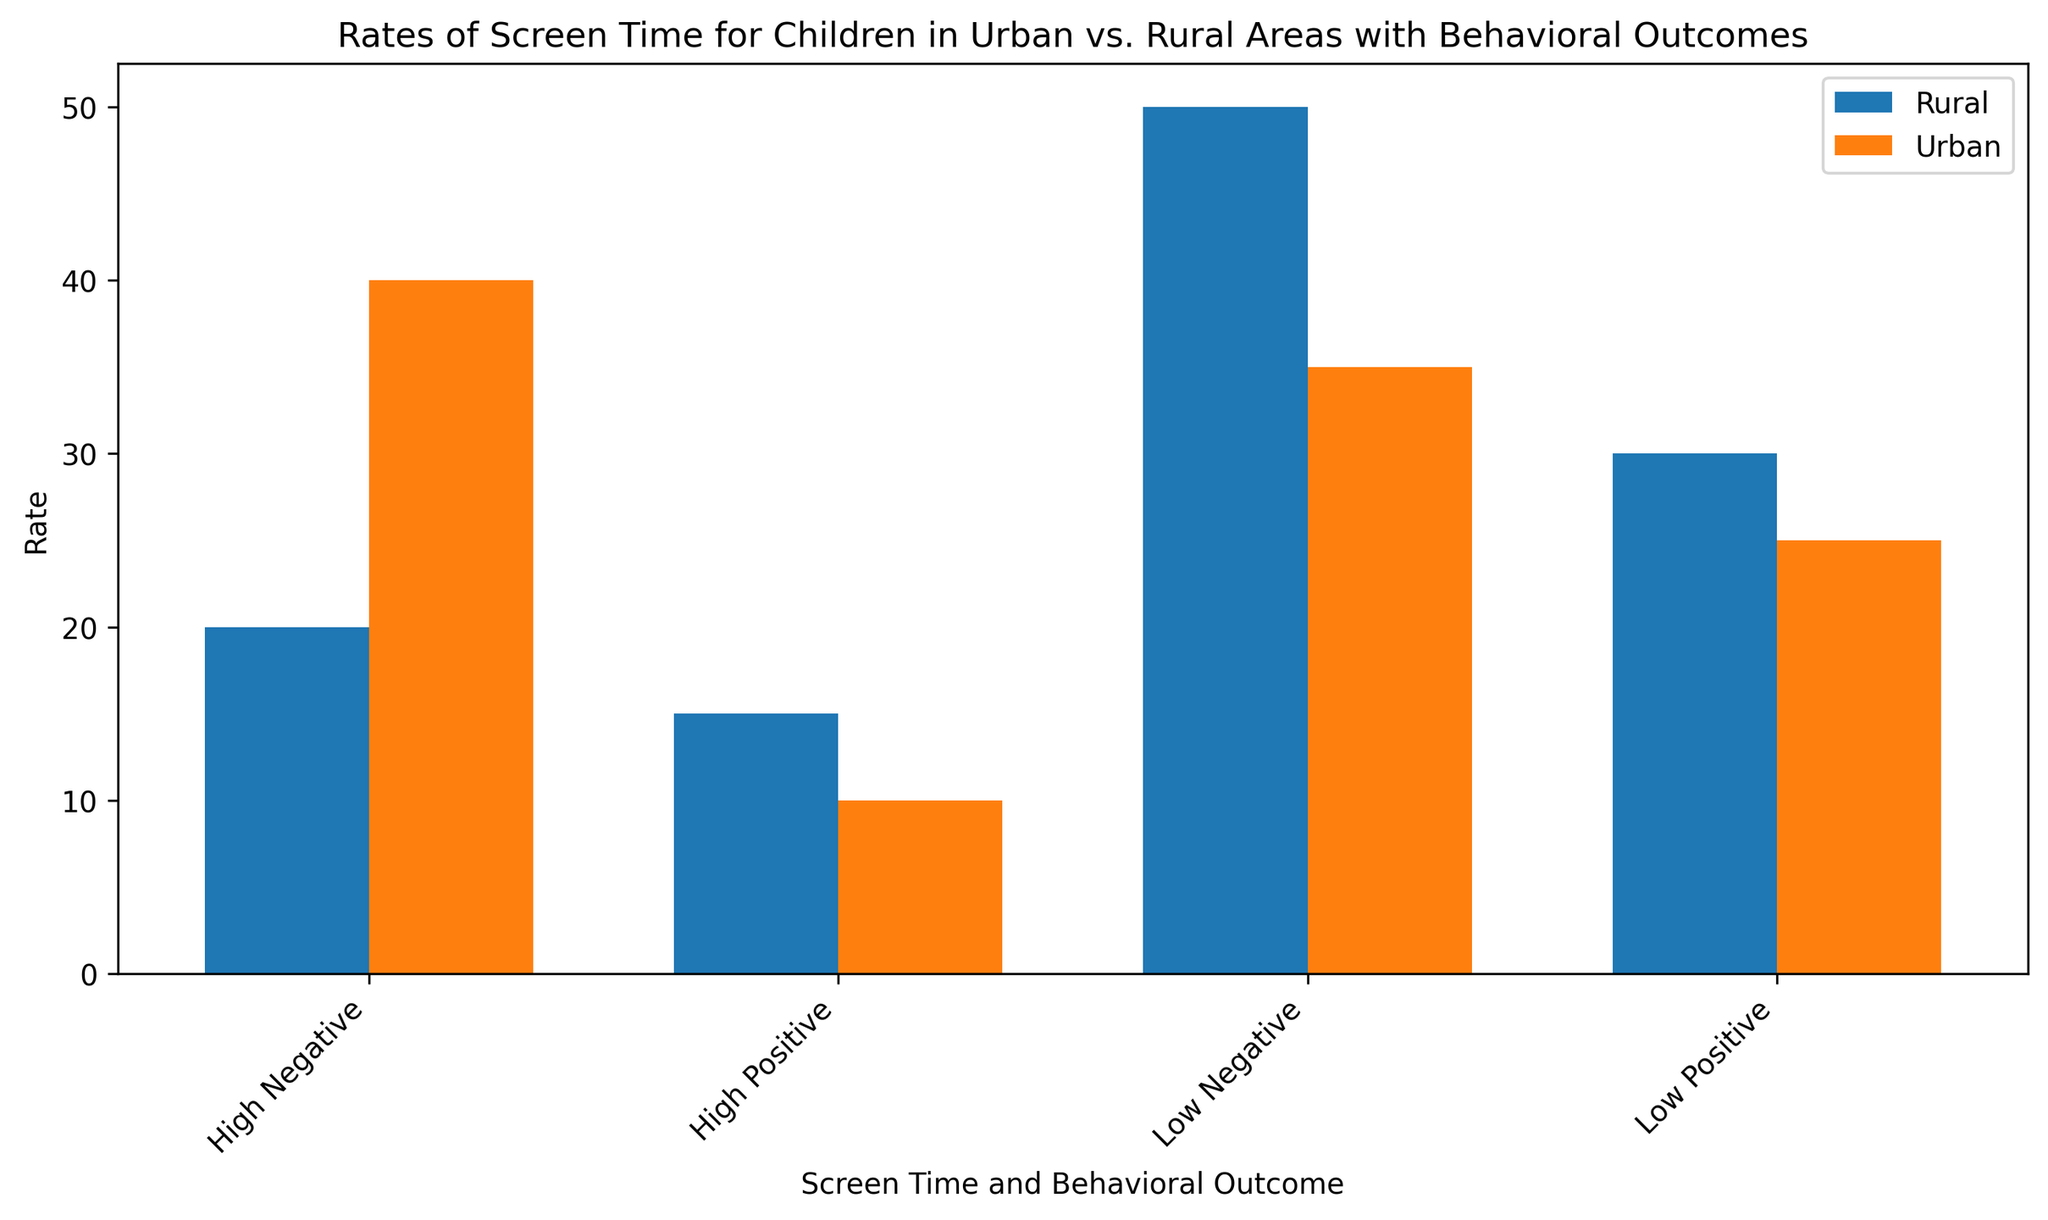What's the rate of children in urban areas who have high positive outcomes? To find this, look for the bar labeled "High Positive" under the urban area, and read its height or value.
Answer: 10 Which area has a higher rate of children with low negative screen time outcomes? Compare the bars labeled "Low Negative" for both urban and rural areas. The bar with higher height indicates the area with a greater rate.
Answer: Rural What is the combined rate for children in rural areas with good and excellent behavioral outcomes? Add the rates for "Low Positive" and "High Positive" in Rural: 30 (Good) + 15 (Excellent) = 45
Answer: 45 Which area shows a higher rate of children with poor behavioral outcomes? Look at the bars labeled "High Negative" for both urban and rural areas. The taller bar represents a higher rate.
Answer: Urban How much higher is the rate of children with fair behavioral outcomes in rural areas compared to urban areas? Subtract the "Low Negative" rate in urban from the same in rural: 50 (Rural) - 35 (Urban) = 15
Answer: 15 What is the average rate of children with positive behavioral outcomes across both areas? Calculate the average of all positive outcomes: (25 + 10 + 30 + 15) / 4 = 80 / 4 = 20
Answer: 20 In which area is the rate of children with high negative screen time outcomes the lowest? Compare the bars for "High Negative" in both areas; the shorter bar indicates the lower rate.
Answer: Rural What is the total rate for urban children across all behavioral outcomes? Sum all rates for urban: 25 (Good) + 40 (Poor) + 35 (Fair) + 10 (Excellent) = 110
Answer: 110 In which area do children exhibit a higher rate of positive behavioral outcomes? Compare both "Low Positive" and "High Positive" bars for both areas, and sum them for each area: Urban (25 + 10 = 35) and Rural (30 + 15 = 45). The higher total indicates a higher rate.
Answer: Rural 